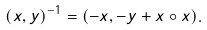Convert formula to latex. <formula><loc_0><loc_0><loc_500><loc_500>( x , y ) ^ { - 1 } = ( - x , - y + x \circ x ) .</formula> 